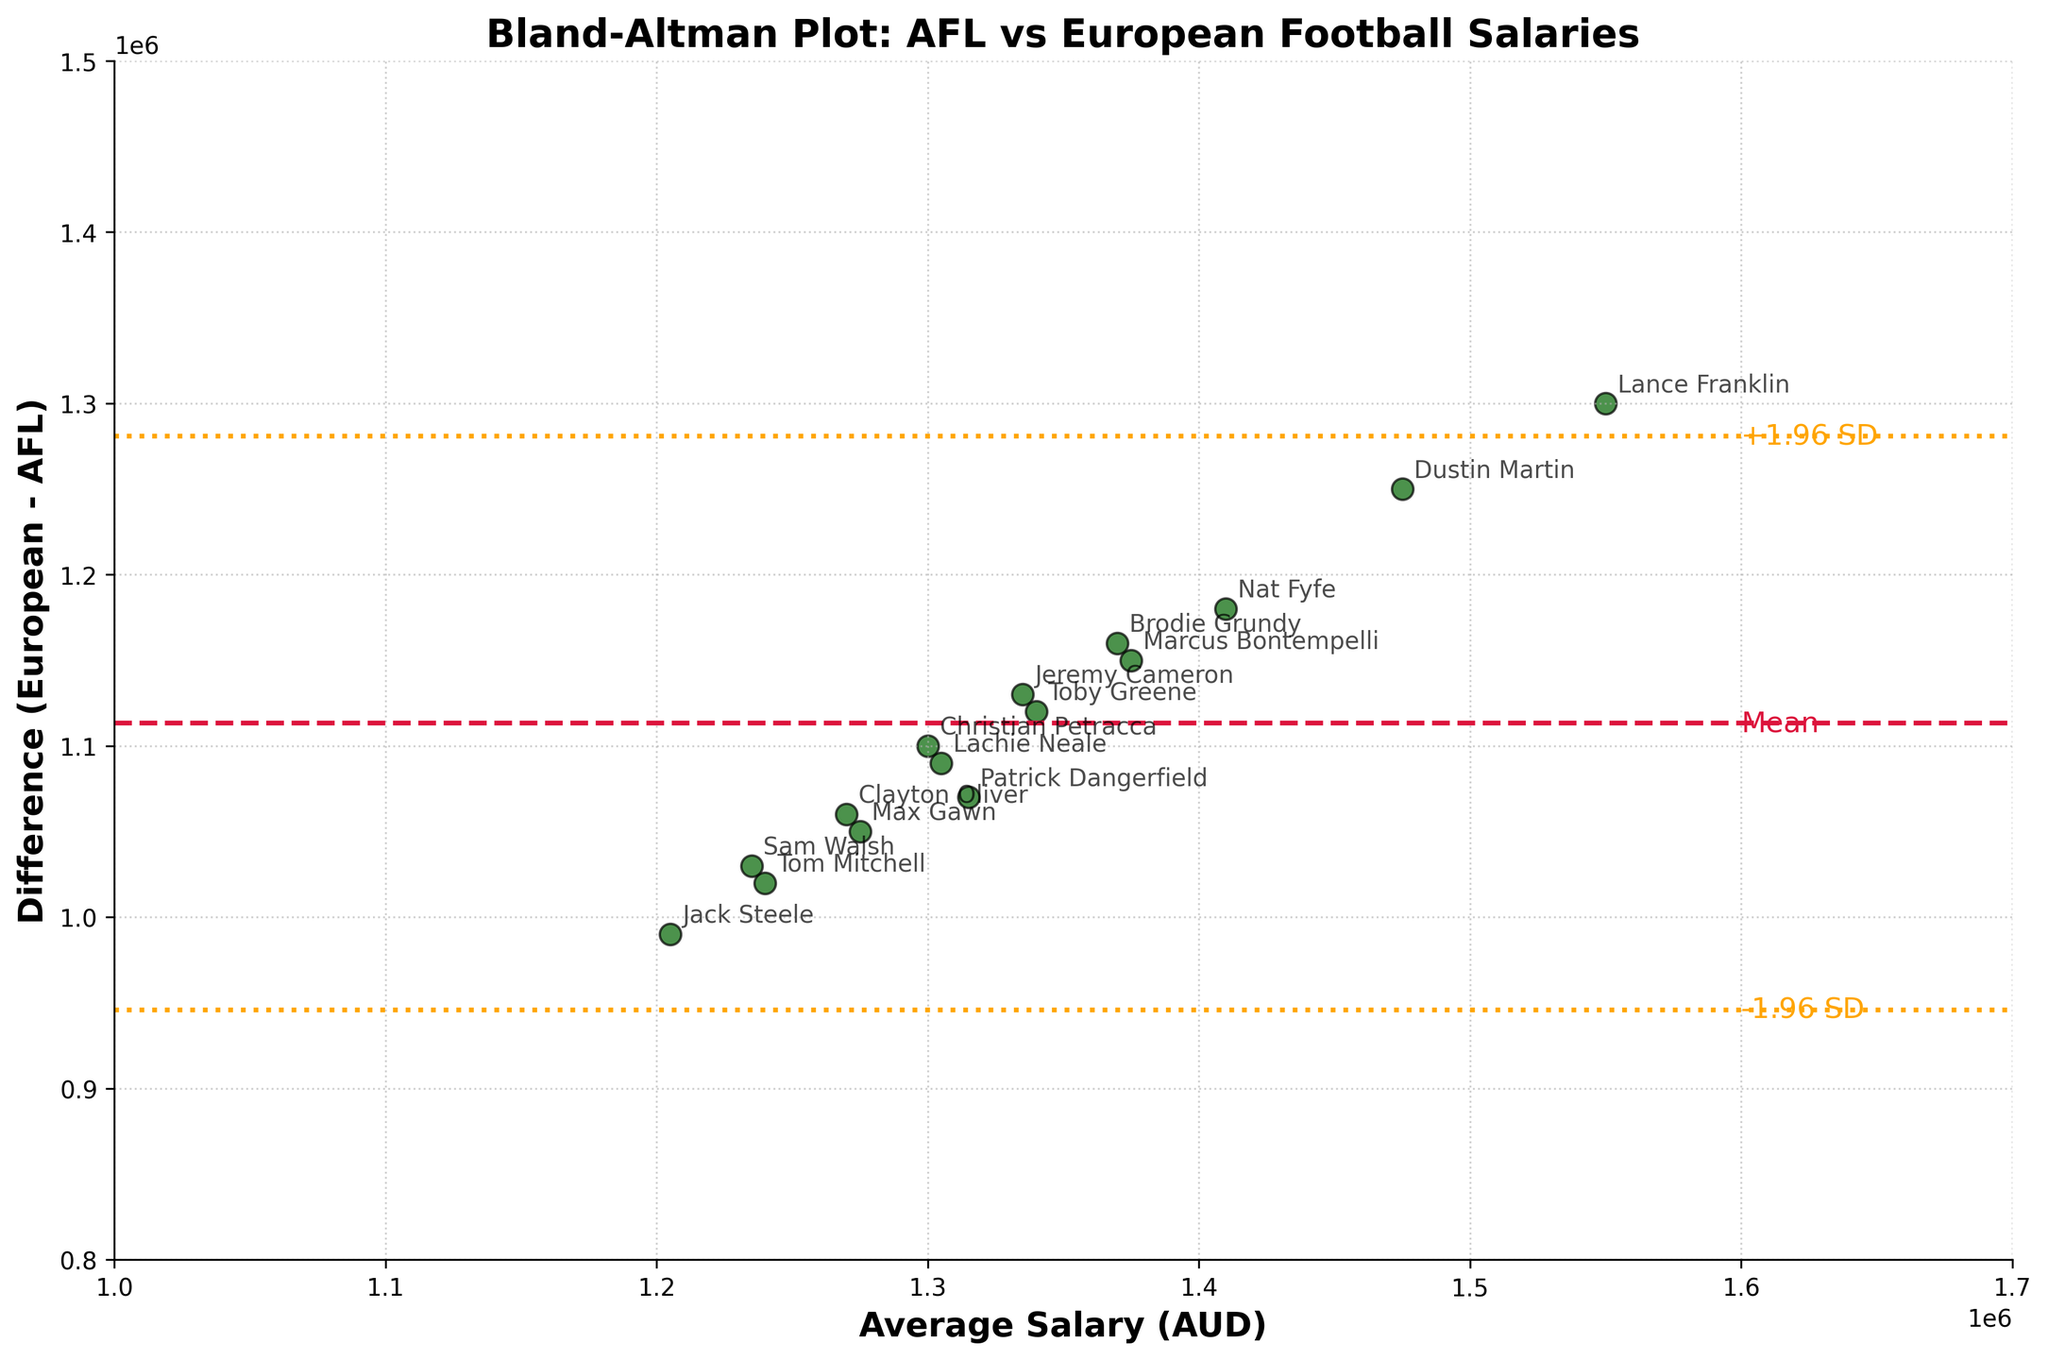What is the title of the plot? The title is typically located at the top of the plot and is in bold text, indicating the general content of the plot.
Answer: Bland-Altman Plot: AFL vs European Football Salaries How many data points are plotted? Each player's average salary and the difference between their AFL and European salaries are represented by a point. Counting each dot gives the total number of data points.
Answer: 15 What do the dashed horizontal lines represent? In a Bland-Altman plot, the dashed lines indicate the mean difference and the limits of agreement (mean difference ± 1.96 times the standard deviation of the differences). These lines are color-coded (crimson for the mean and orange for the limits).
Answer: Mean and ±1.96 SD Which player has the highest average salary? By looking at the x-axis, identify the furthest point to the right and check the player label nearest to that point.
Answer: Lance Franklin What is the average difference in salary between European leagues and AFL? The mean difference is represented by the crimson dashed line. This value can be read off the y-axis at the point where this line intersects.
Answer: Approximately 1.1 million AUD Do any players' salaries fall outside the ±1.96 SD limits? Points outside the orange dashed lines indicate players whose salary differences fall outside these limits. Observing the plot confirms whether any such points are present.
Answer: No Are European league salaries generally higher or lower than AFL salaries? The plot displays the difference (European - AFL). Most points above the x-axis indicate higher European salaries, whereas points below indicate lower.
Answer: Higher What is the range of average player salaries? By examining the x-axis and noting the minimum and maximum average salary values among the plotted points, the range can be determined.
Answer: 1.2 million to 1.55 million AUD How does the variability of differences change across the salary range? Check if the spread of the points (variability) increases or decreases from left to right along the x-axis (average salaries). Note if it's consistent or varies.
Answer: Relatively consistent across the range Which players' salaries are most and least different between European leagues and AFL? The y-axis shows the difference in salaries. The highest point indicates the greatest difference, and the lowest point indicates the least difference between the two salaries.
Answer: Most: Lance Franklin, Least: Jack Steele 